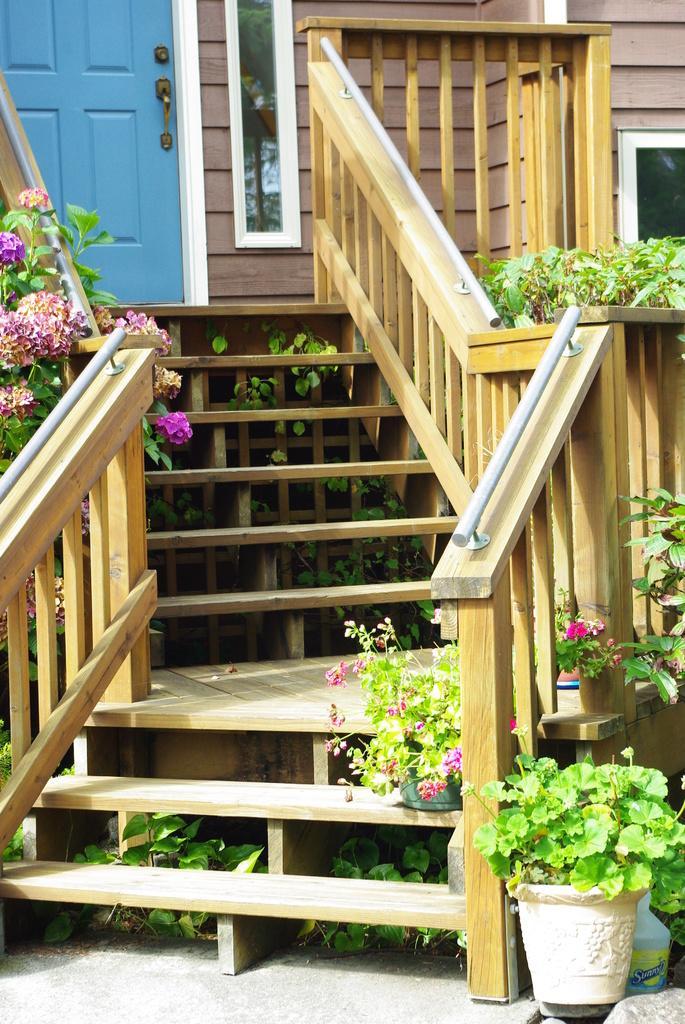Describe this image in one or two sentences. Here we can see steps, door and plants with flowers. 